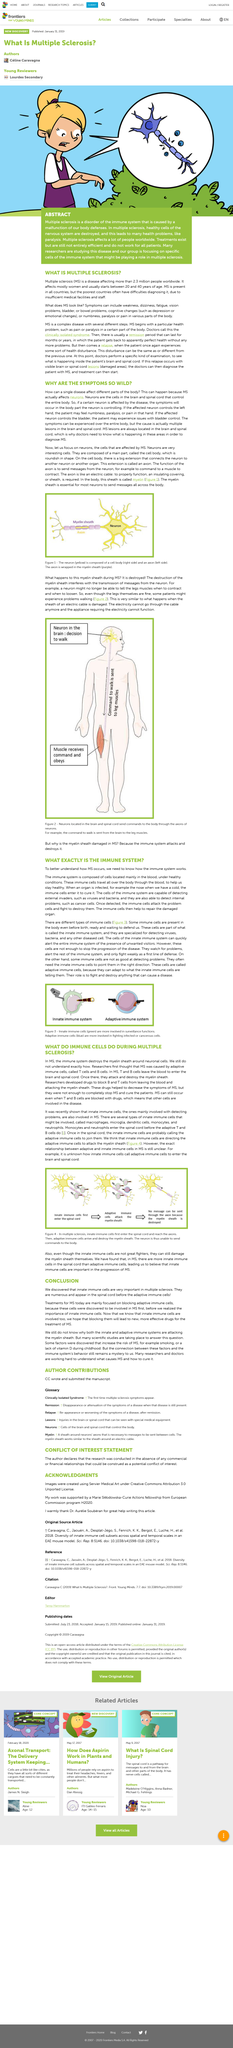List a handful of essential elements in this visual. The axons of neurons can be connected to other neurons or other organs in the body. Cells of the immune system are capable of detecting and responding to external invaders such as viruses and bacteria. Multiple sclerosis (MS) is a chronic autoimmune disease that affects the central nervous system, which includes the brain and spinal cord. The lesions associated with MS typically appear in these areas. The immune system, under healthy conditions, is composed primarily of cells that are located in the bloodstream. These cells play a vital role in defending the body against foreign invaders, such as bacteria and viruses. The diagnosis of Multiple Sclerosis (MS) can be made by doctors when they observe visible brain or spinal cord lesions, as well as other symptoms such as muscle weakness, numbness, and vision problems. The treatment for MS typically begins as soon as the diagnosis is made, and may include medications to reduce inflammation, physical therapy to improve mobility and manage symptoms, and other supportive care as needed. The goal of treatment is to help manage the symptoms of MS and slow the progression of the disease. 